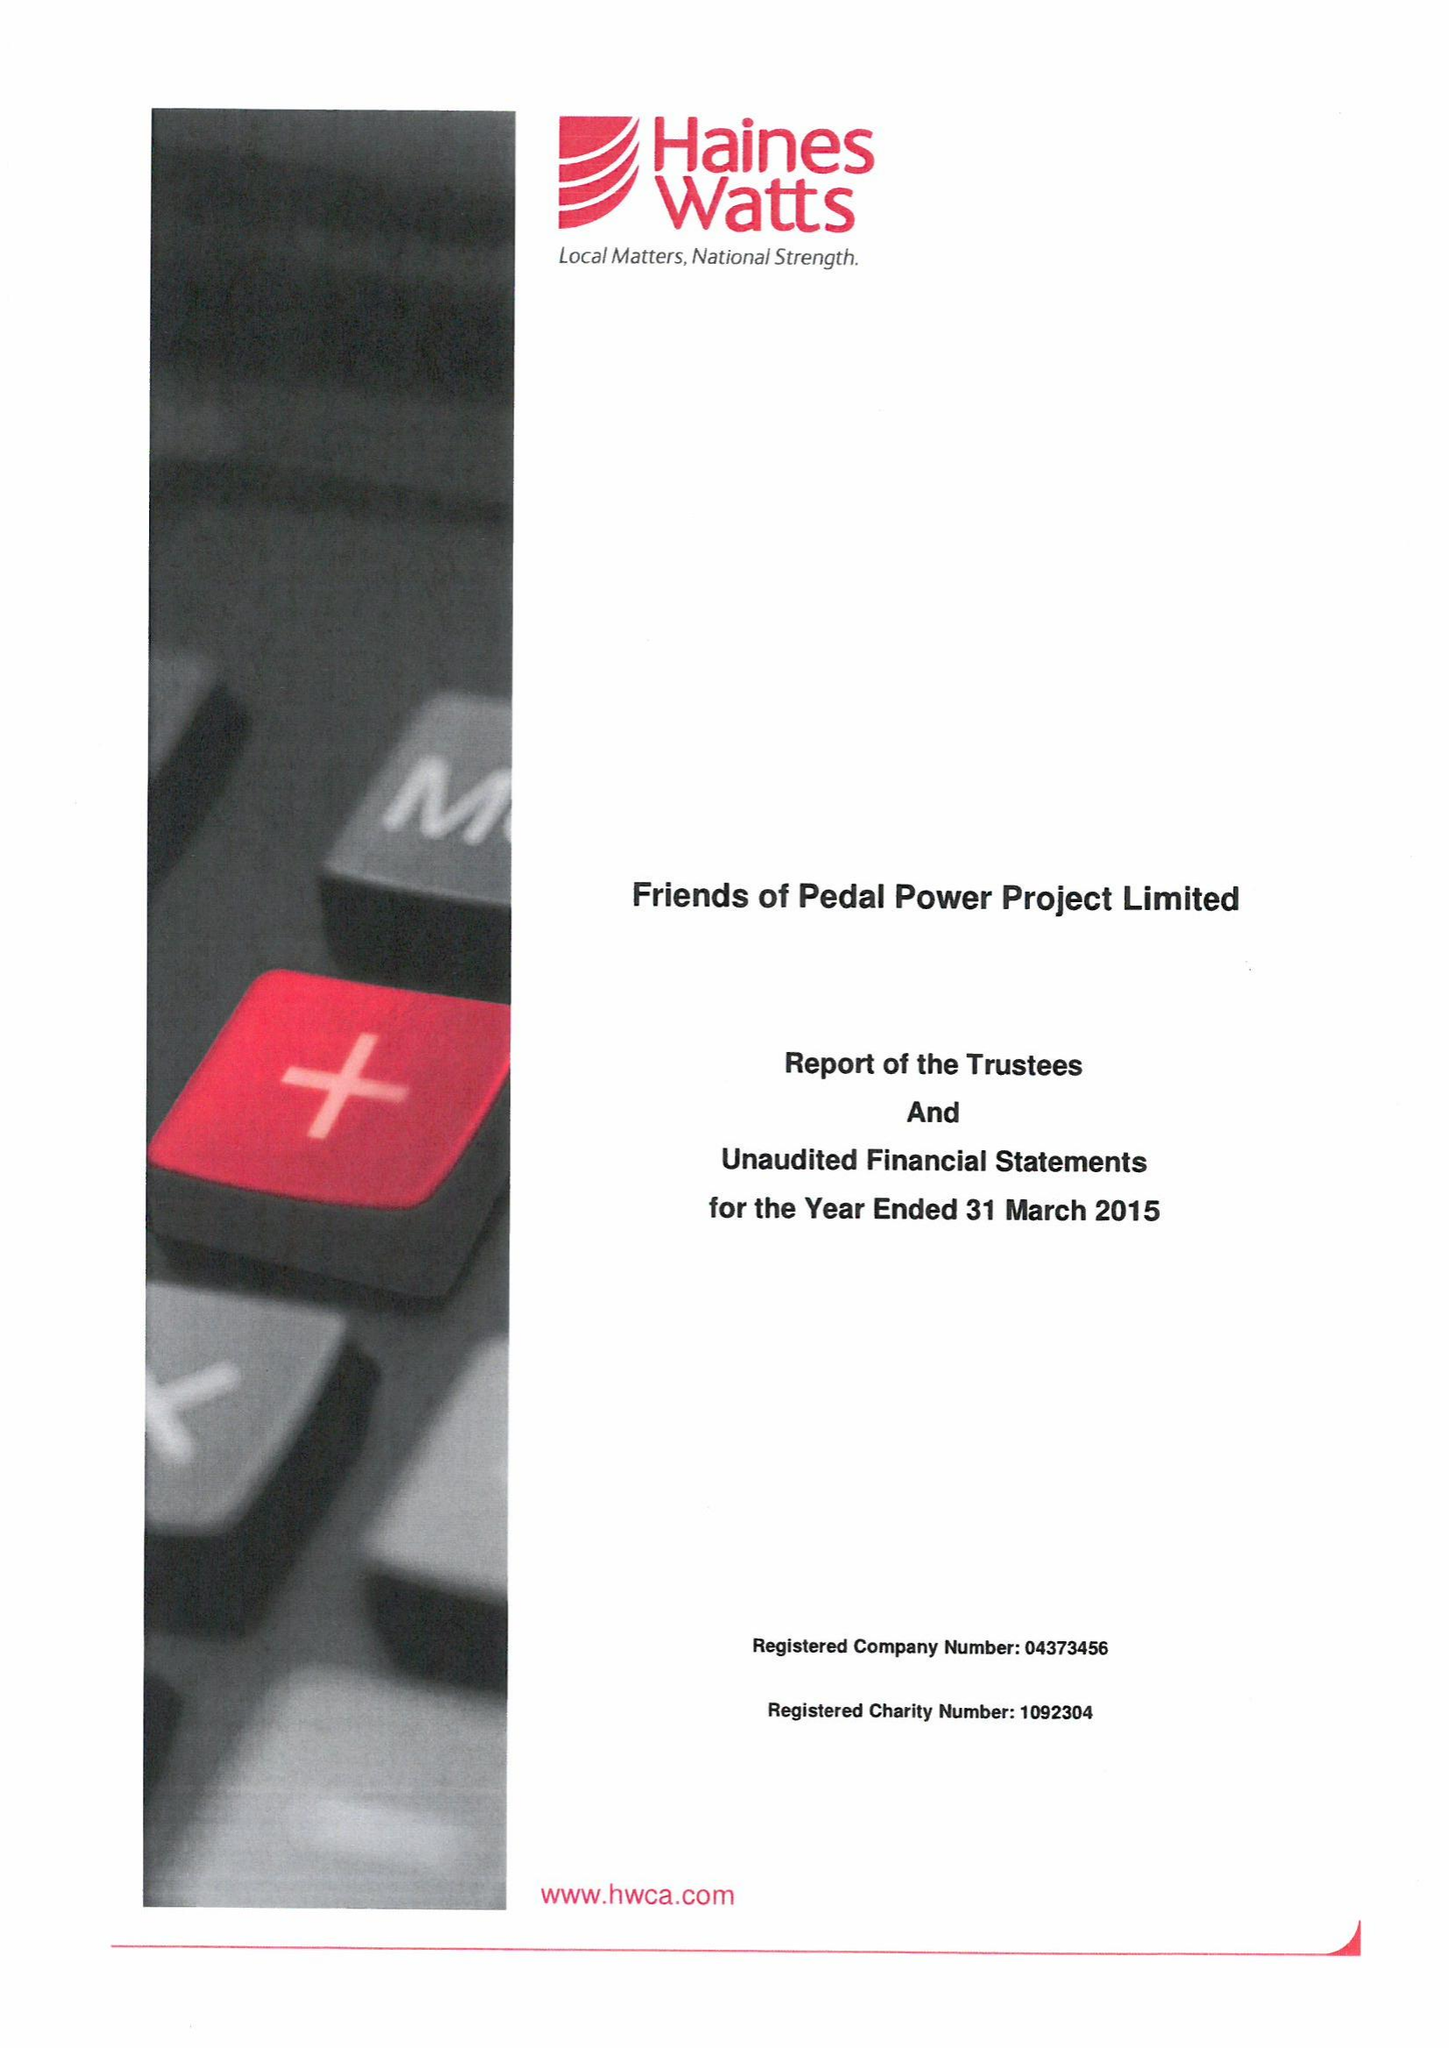What is the value for the charity_number?
Answer the question using a single word or phrase. 1092304 